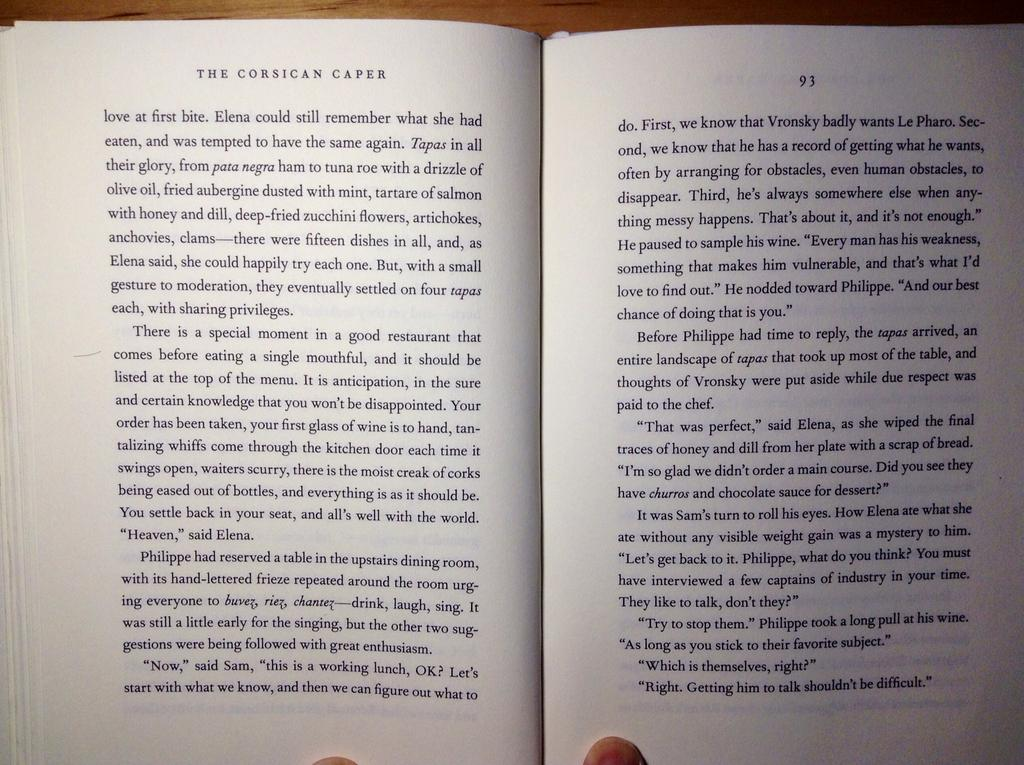Provide a one-sentence caption for the provided image. Pages 92 and 93 of The Corsican Caper are shown being held open by two fingers. 